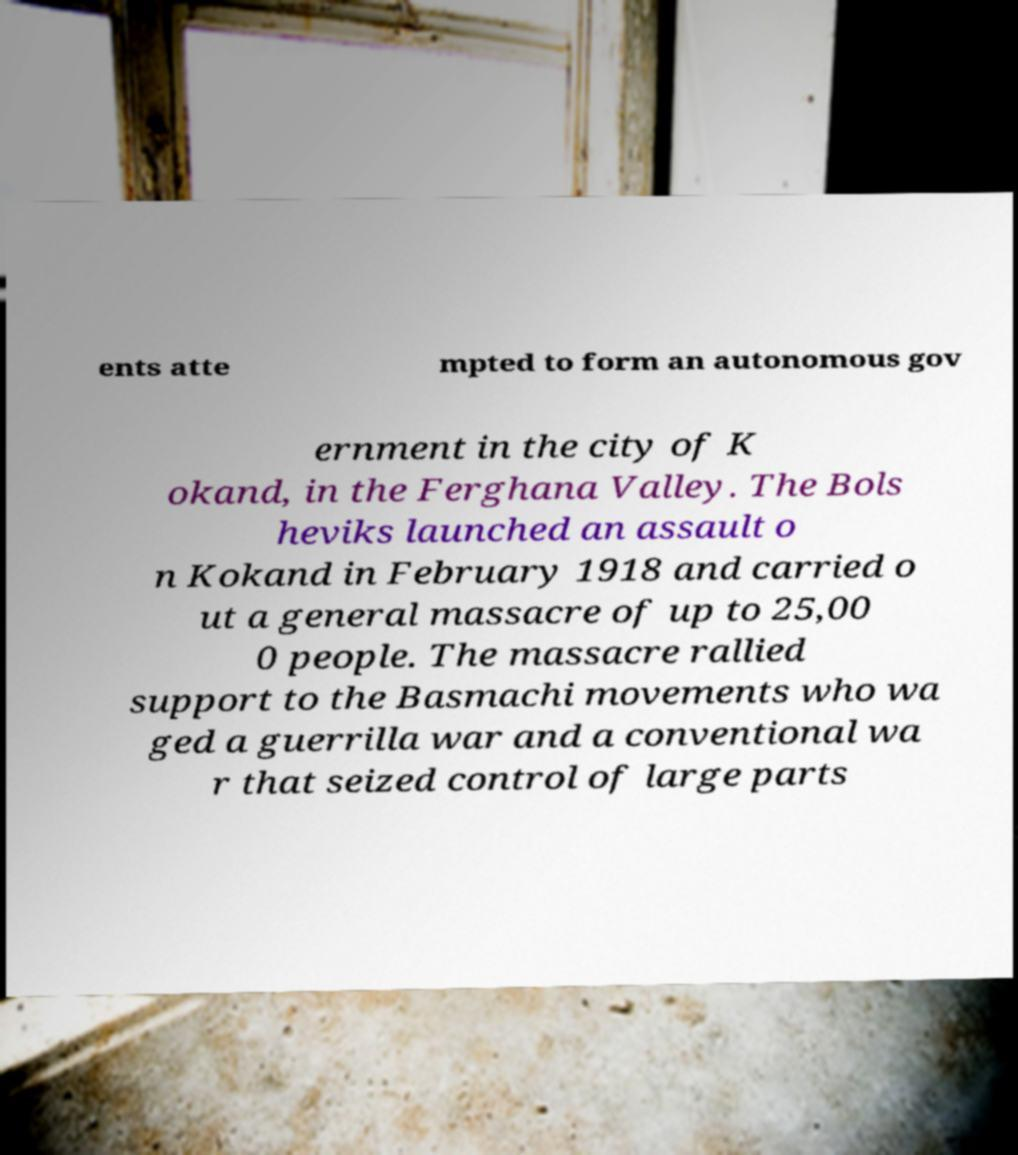Can you read and provide the text displayed in the image?This photo seems to have some interesting text. Can you extract and type it out for me? ents atte mpted to form an autonomous gov ernment in the city of K okand, in the Ferghana Valley. The Bols heviks launched an assault o n Kokand in February 1918 and carried o ut a general massacre of up to 25,00 0 people. The massacre rallied support to the Basmachi movements who wa ged a guerrilla war and a conventional wa r that seized control of large parts 